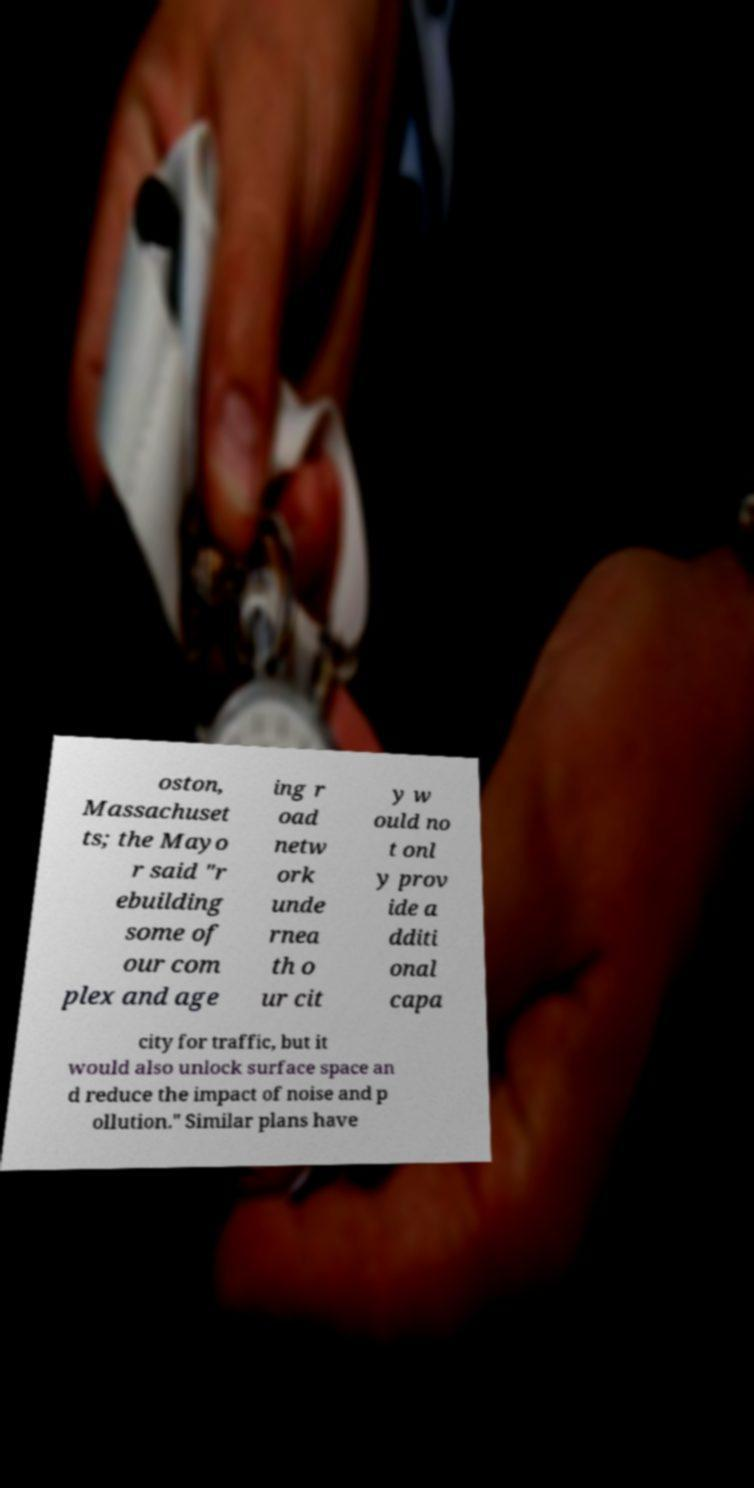There's text embedded in this image that I need extracted. Can you transcribe it verbatim? oston, Massachuset ts; the Mayo r said "r ebuilding some of our com plex and age ing r oad netw ork unde rnea th o ur cit y w ould no t onl y prov ide a dditi onal capa city for traffic, but it would also unlock surface space an d reduce the impact of noise and p ollution." Similar plans have 